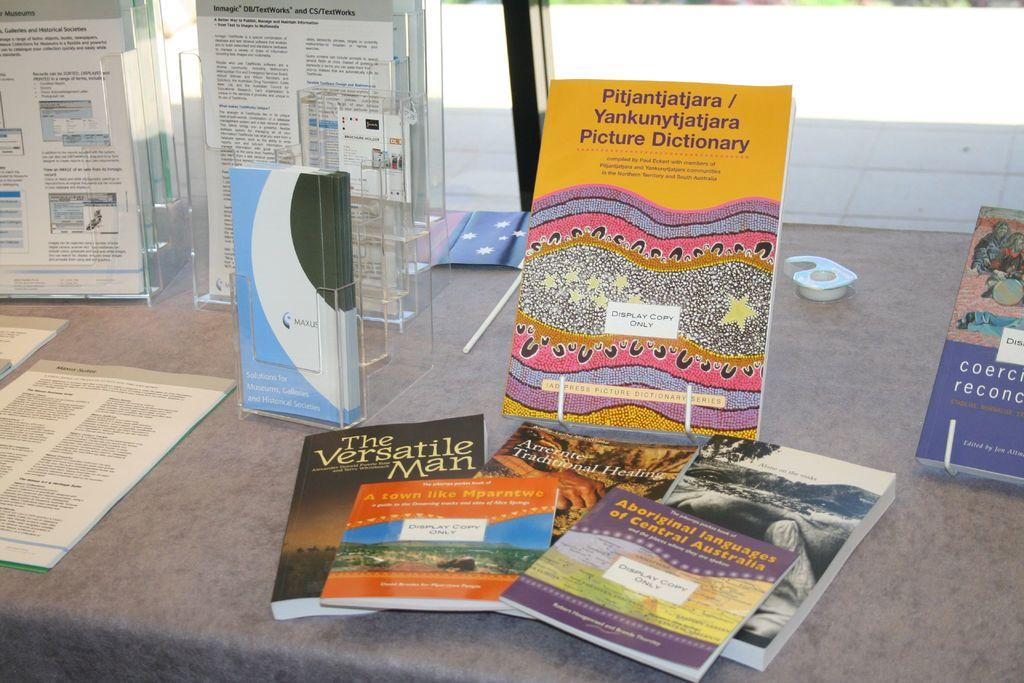<image>
Relay a brief, clear account of the picture shown. A collection of paperback books include a picture dictionary and a book about language. 